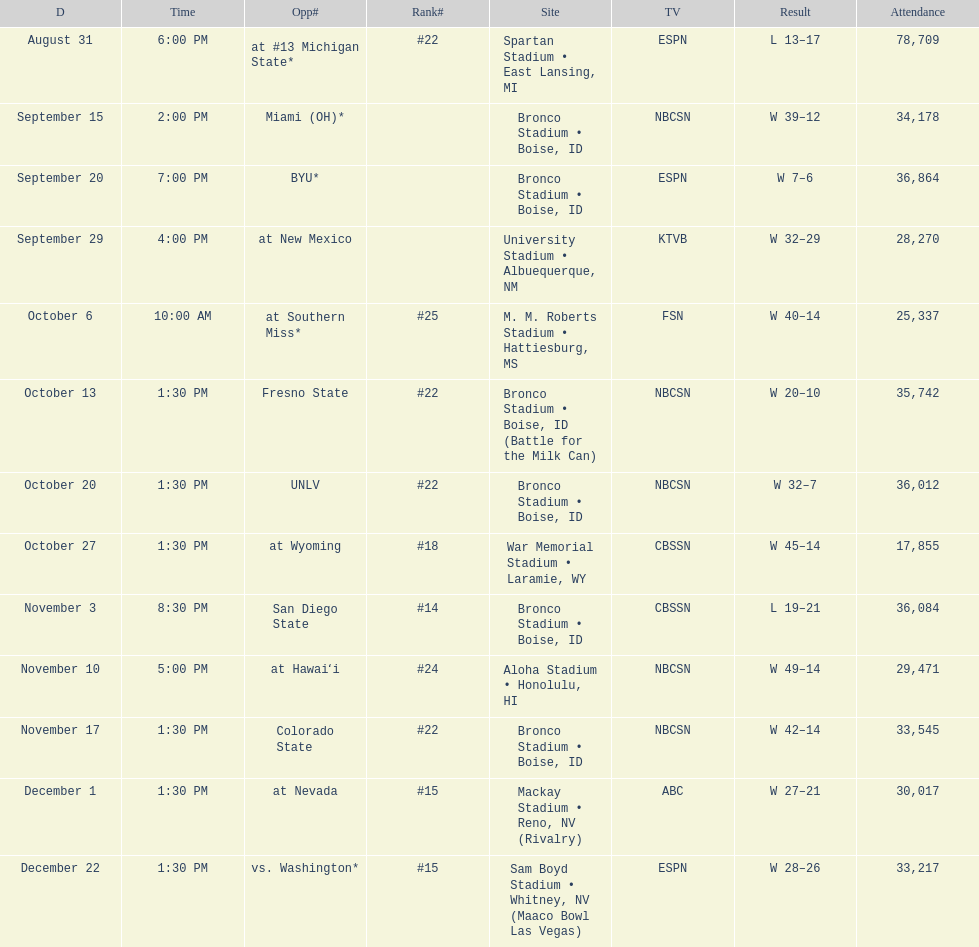What is the total number of games played at bronco stadium? 6. 